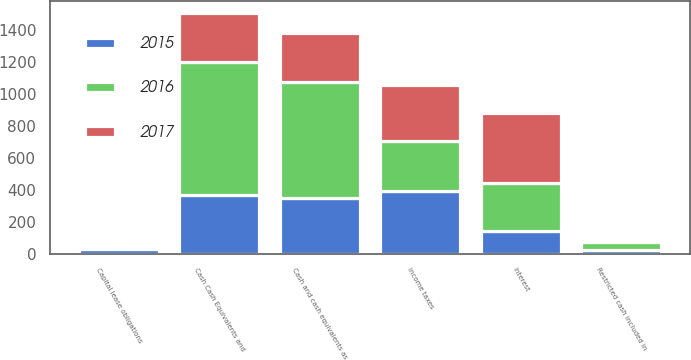Convert chart. <chart><loc_0><loc_0><loc_500><loc_500><stacked_bar_chart><ecel><fcel>Interest<fcel>Income taxes<fcel>Capital lease obligations<fcel>Cash and cash equivalents as<fcel>Restricted cash included in<fcel>Cash Cash Equivalents and<nl><fcel>2017<fcel>442<fcel>346<fcel>8<fcel>305.5<fcel>17<fcel>305.5<nl><fcel>2016<fcel>297<fcel>314<fcel>10<fcel>725<fcel>51<fcel>831<nl><fcel>2015<fcel>141<fcel>392<fcel>26<fcel>345<fcel>20<fcel>365<nl></chart> 